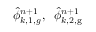<formula> <loc_0><loc_0><loc_500><loc_500>\hat { \phi } _ { k , 1 , g } ^ { n + 1 } , \, \hat { \phi } _ { k , 2 , g } ^ { n + 1 }</formula> 